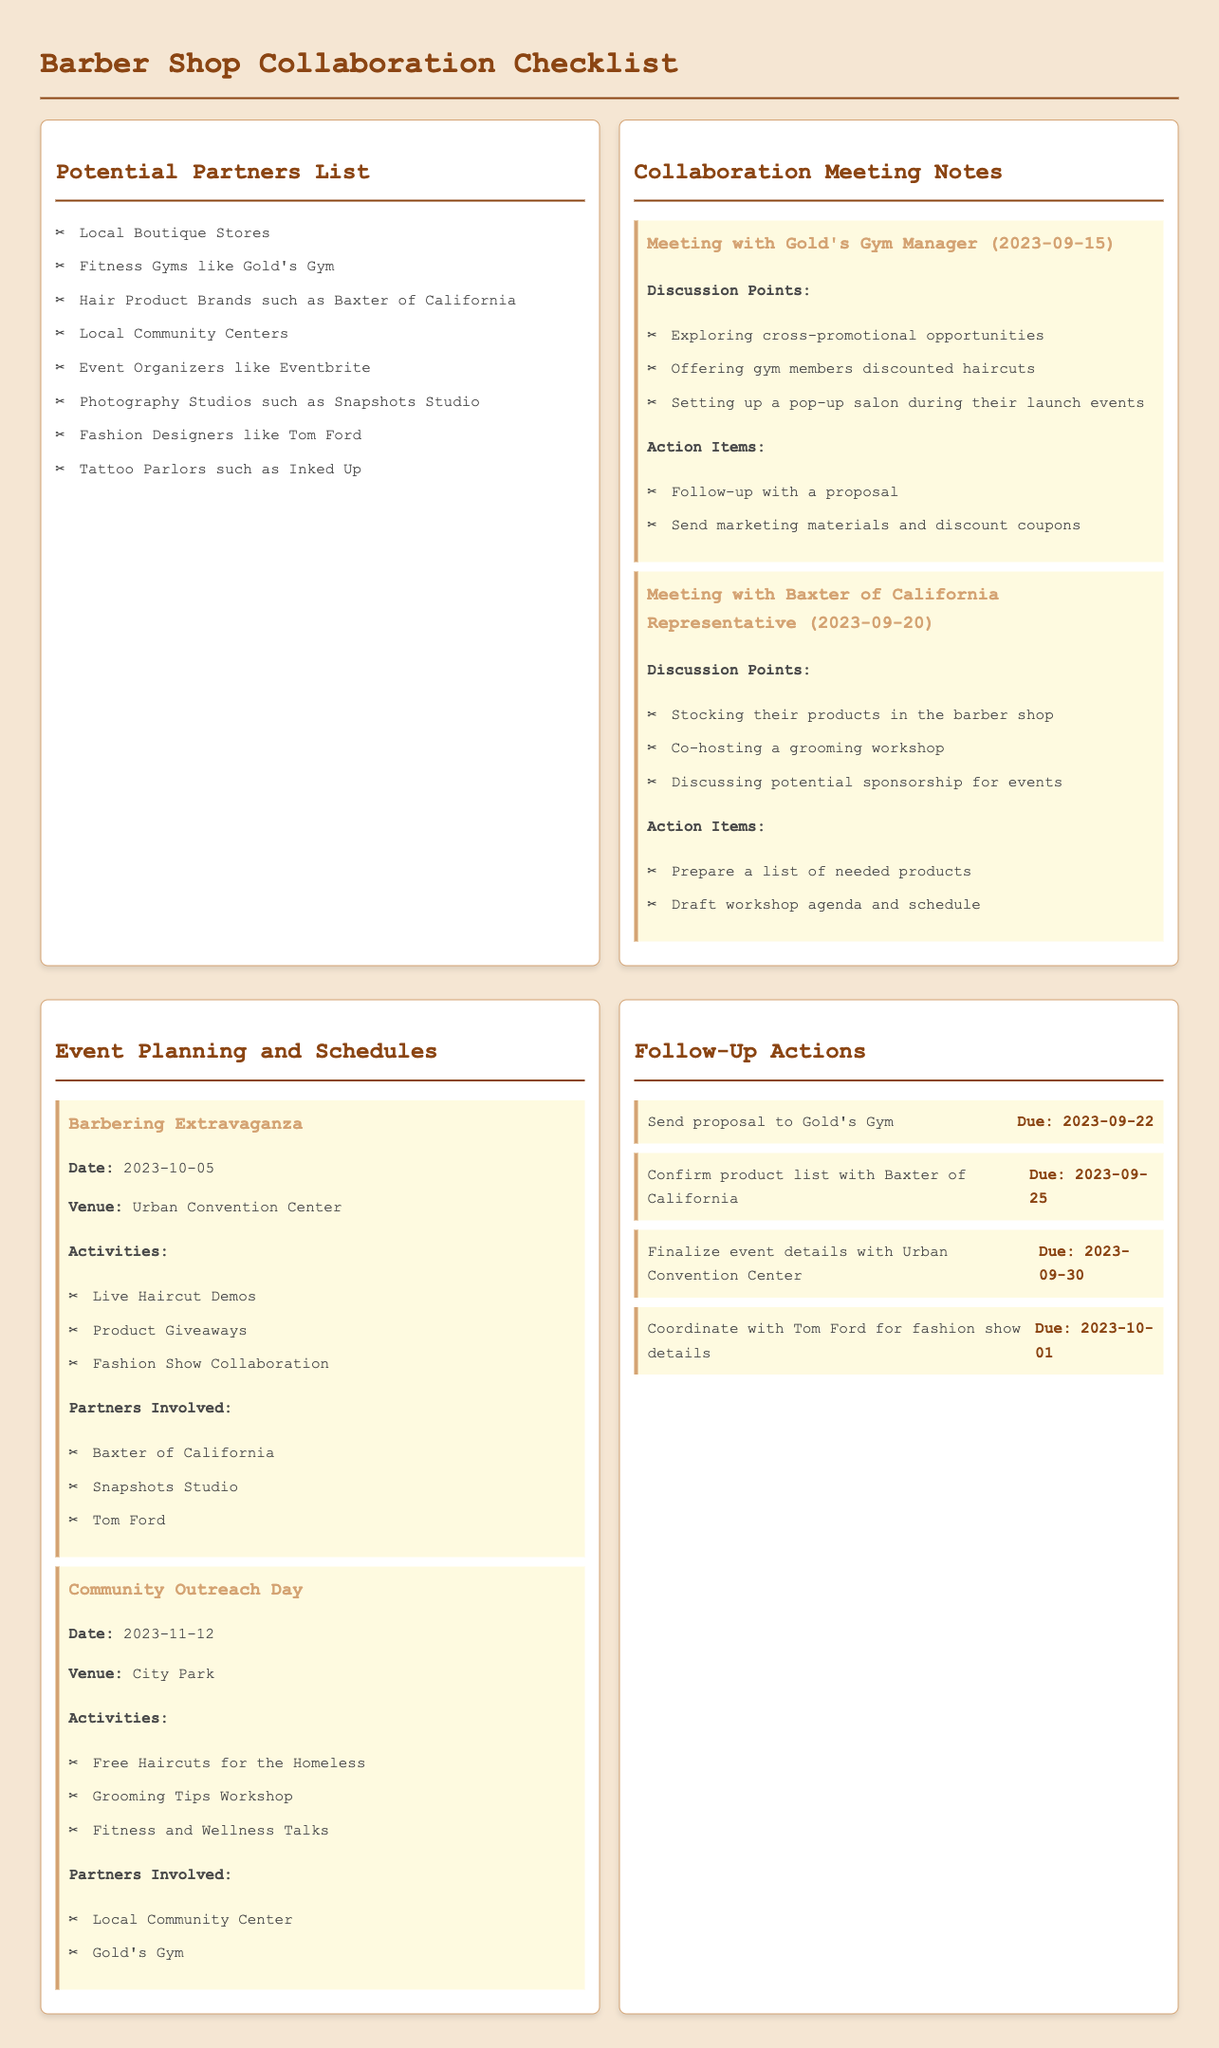What is the date of the Barbering Extravaganza? The date for the event is stated explicitly in the document under Event Planning and Schedules.
Answer: 2023-10-05 Who is a potential partner involved in the Community Outreach Day? The document lists partners involved in the Community Outreach Day under Event Planning and Schedules, which includes several entities.
Answer: Gold's Gym What is one of the discussion points from the meeting with Baxter of California? Specific discussion points are outlined in the Collaboration Meeting Notes section of the document.
Answer: Stocking their products in the barber shop How many action items are listed under Follow-Up Actions? The action items are enumerated in the Follow-Up Actions section of the document, indicating the number present.
Answer: Four What type of event is scheduled for November 12, 2023? The document categorizes events, and the type for the scheduled date is mentioned under Event Planning and Schedules.
Answer: Community Outreach Day Who will be involved in the fashion show at Barbering Extravaganza? Involvement in the fashion show is mentioned alongside partners in the Event Planning and Schedules section of the document.
Answer: Tom Ford What action is due on September 30, 2023? The Follow-Up Actions section lists due actions, which allows for identifying a specific action by its due date.
Answer: Finalize event details with Urban Convention Center What is the venue for the Community Outreach Day? The venue for this event is clearly stated under the respective event description in the document.
Answer: City Park 